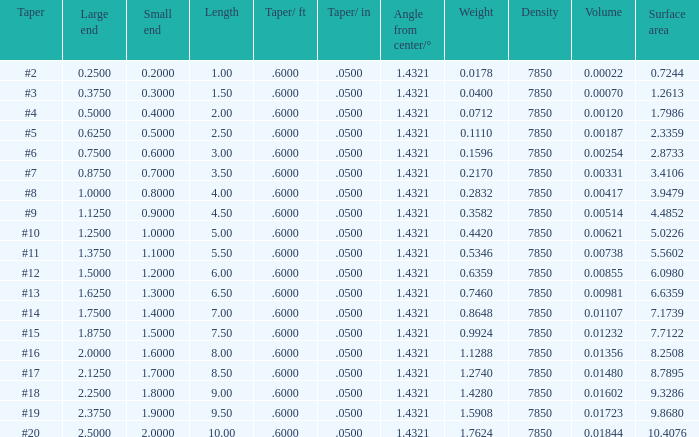Which Taper/in that has a Small end larger than 0.7000000000000001, and a Taper of #19, and a Large end larger than 2.375? None. 